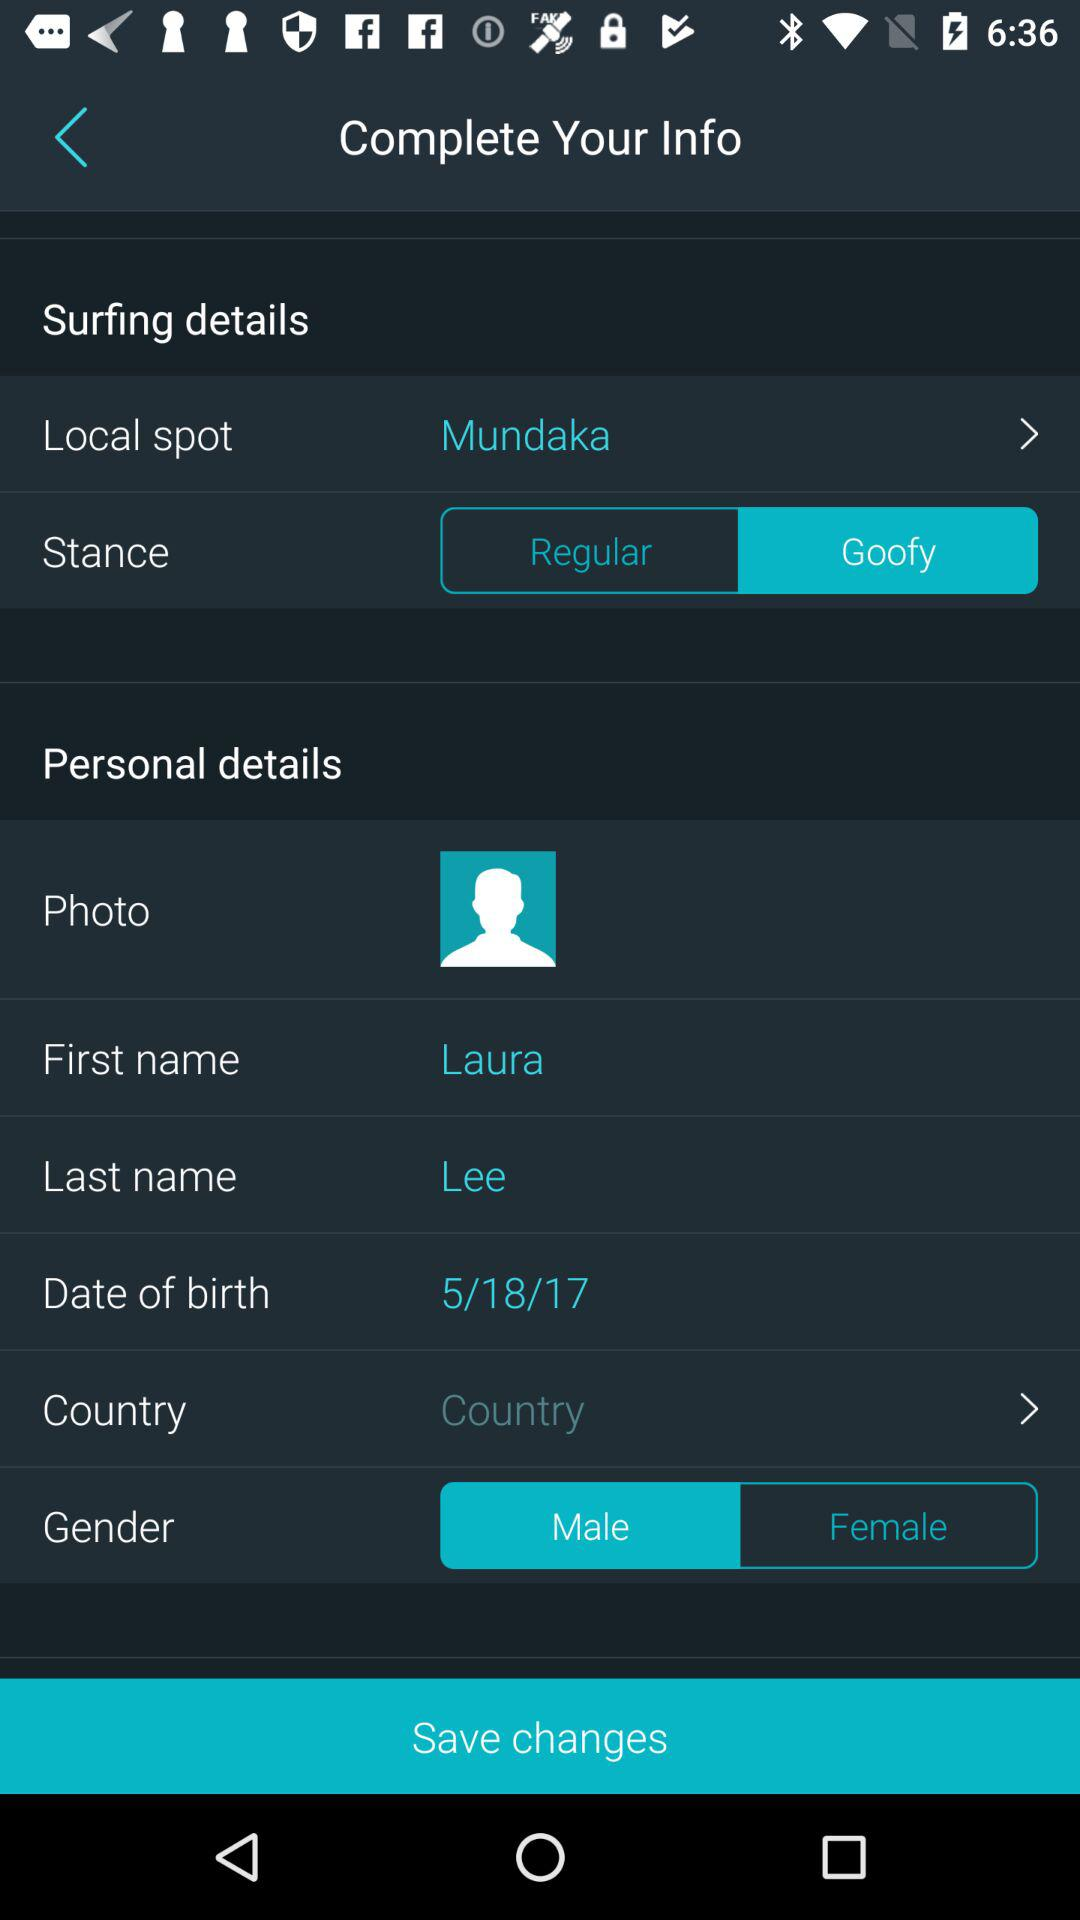How many gender options are available?
Answer the question using a single word or phrase. 2 